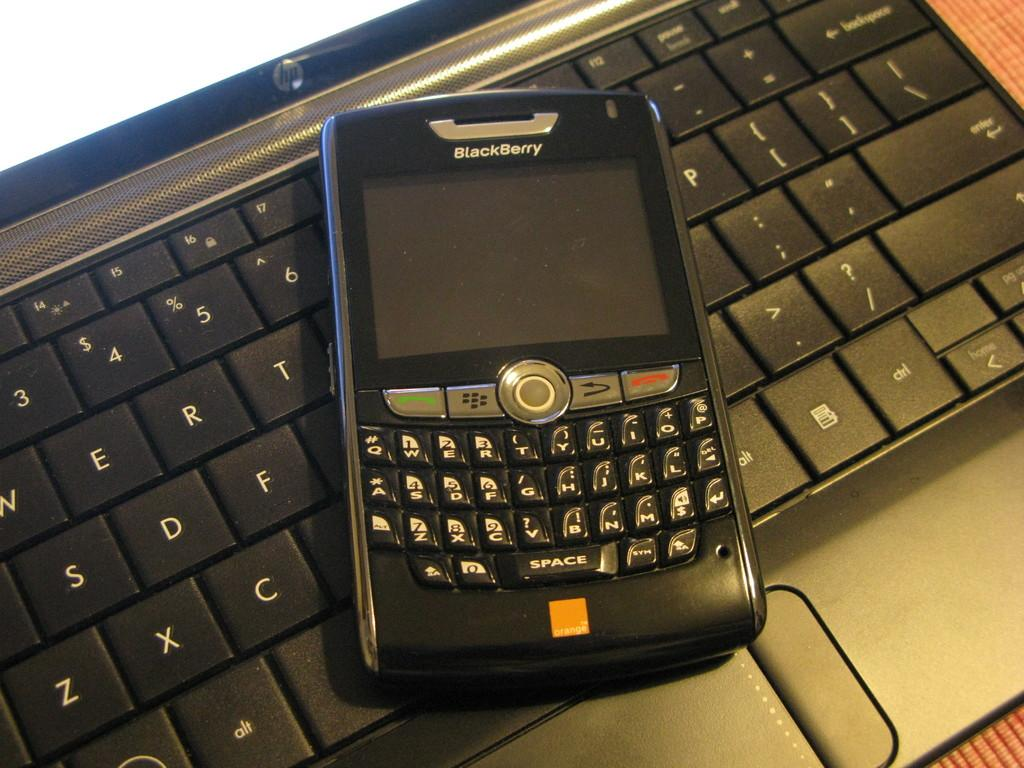Provide a one-sentence caption for the provided image. A blackberry phone sits on top of a laptop keyboard. 